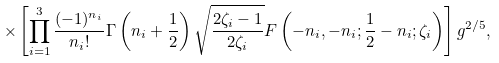Convert formula to latex. <formula><loc_0><loc_0><loc_500><loc_500>\times \left [ \prod _ { i = 1 } ^ { 3 } \frac { ( - 1 ) ^ { n _ { i } } } { n _ { i } ! } \Gamma \left ( n _ { i } + \frac { 1 } { 2 } \right ) \sqrt { \frac { 2 \zeta _ { i } - 1 } { 2 \zeta _ { i } } } F \left ( - n _ { i } , - n _ { i } ; \frac { 1 } { 2 } - n _ { i } ; \zeta _ { i } \right ) \right ] g ^ { 2 / 5 } ,</formula> 